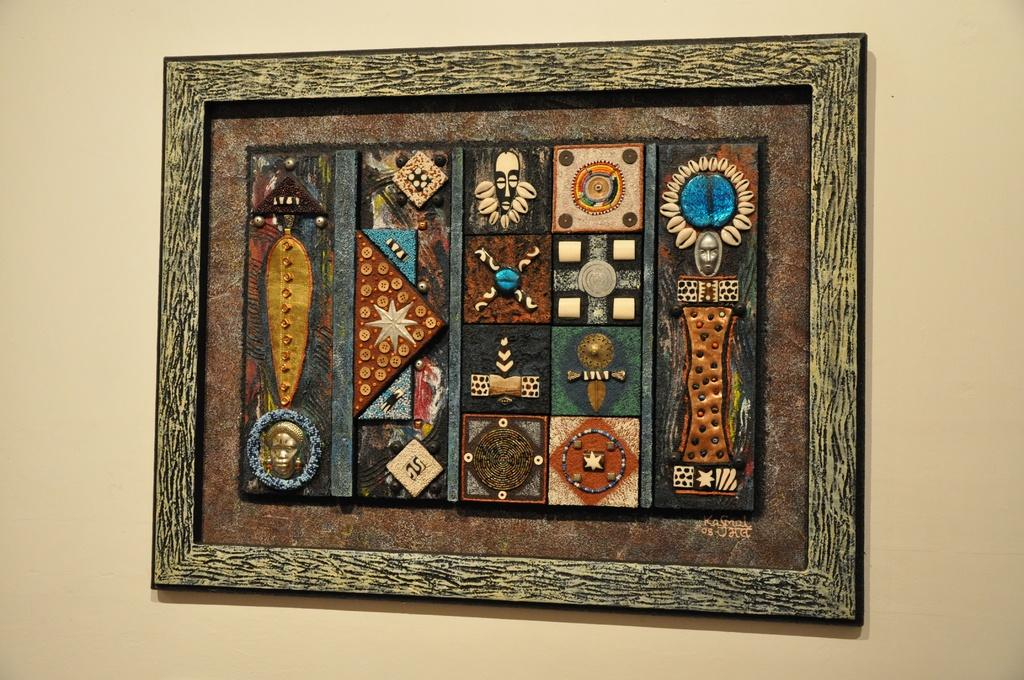What type of structure can be seen in the image? There is a wall in the image. What material is used for the frame of the wall? The wall has a wooden frame. What color is the wall in the image? The wall is in cream color. Can you help me find the tail in the image? There is no tail present in the image; it features a wall with a wooden frame and a cream color. 